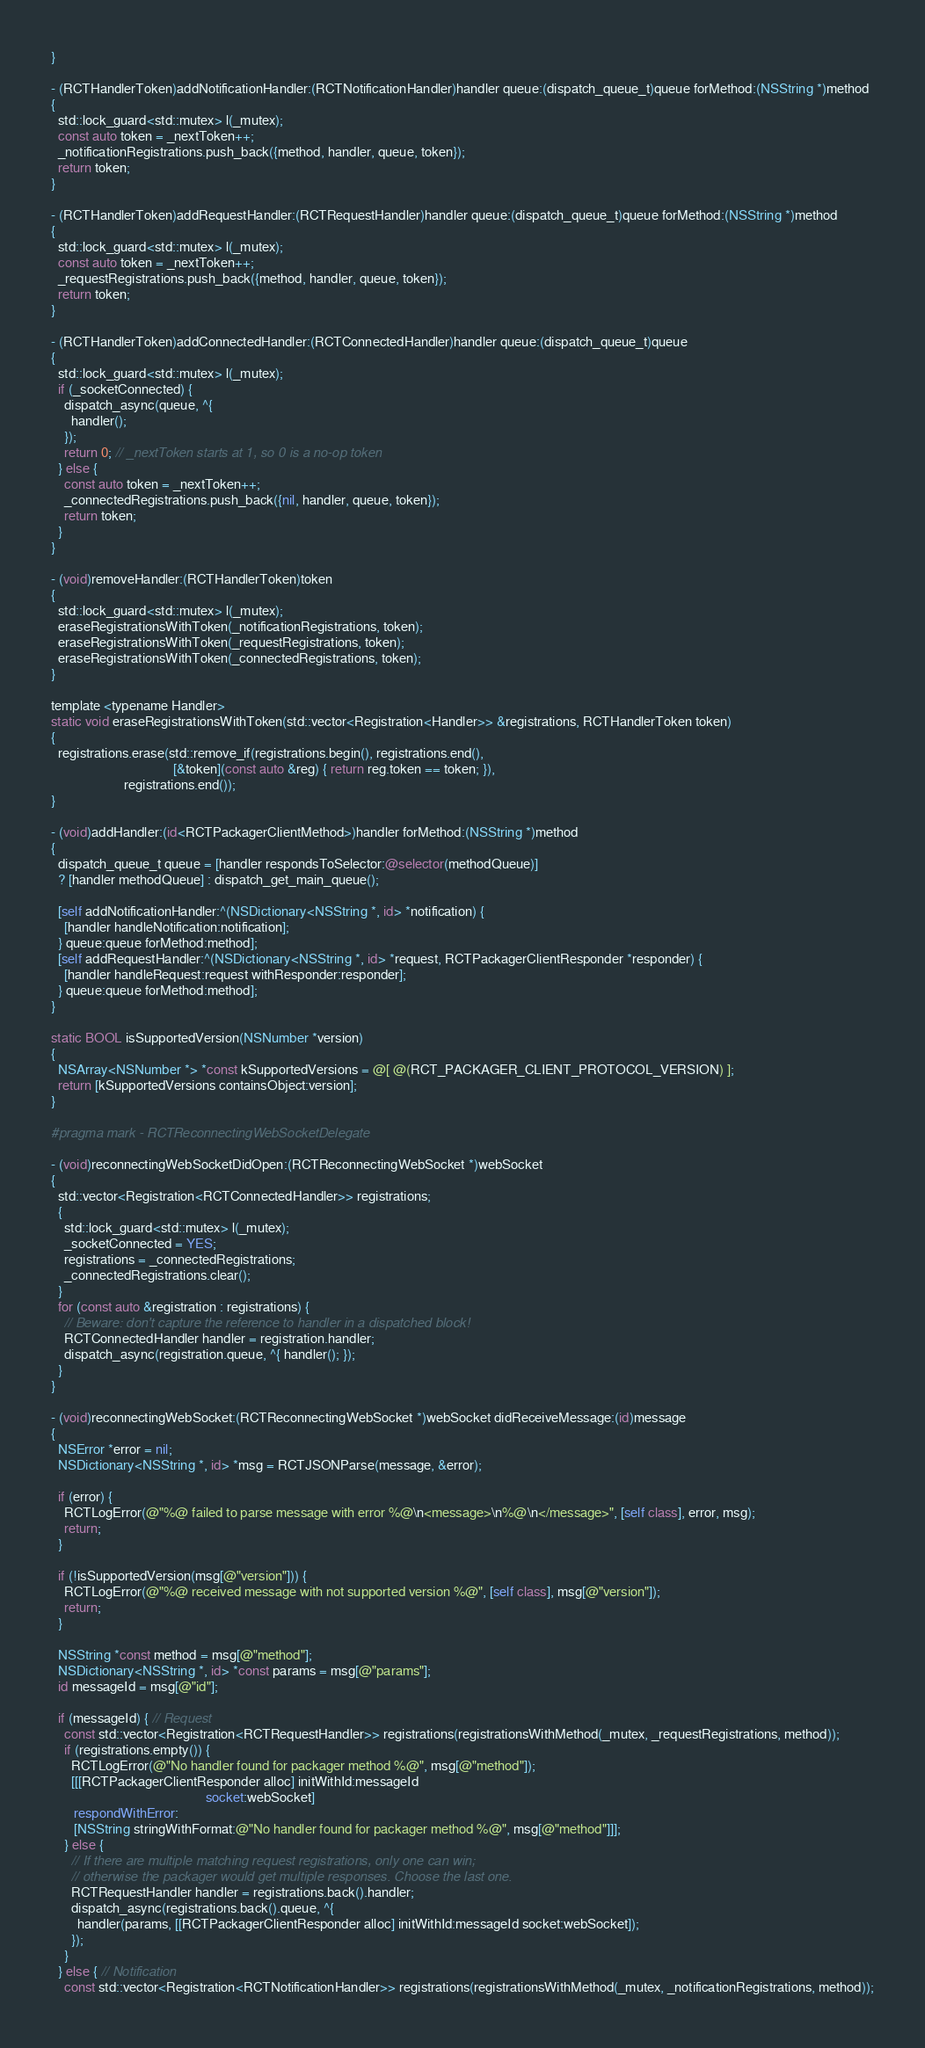<code> <loc_0><loc_0><loc_500><loc_500><_ObjectiveC_>}

- (RCTHandlerToken)addNotificationHandler:(RCTNotificationHandler)handler queue:(dispatch_queue_t)queue forMethod:(NSString *)method
{
  std::lock_guard<std::mutex> l(_mutex);
  const auto token = _nextToken++;
  _notificationRegistrations.push_back({method, handler, queue, token});
  return token;
}

- (RCTHandlerToken)addRequestHandler:(RCTRequestHandler)handler queue:(dispatch_queue_t)queue forMethod:(NSString *)method
{
  std::lock_guard<std::mutex> l(_mutex);
  const auto token = _nextToken++;
  _requestRegistrations.push_back({method, handler, queue, token});
  return token;
}

- (RCTHandlerToken)addConnectedHandler:(RCTConnectedHandler)handler queue:(dispatch_queue_t)queue
{
  std::lock_guard<std::mutex> l(_mutex);
  if (_socketConnected) {
    dispatch_async(queue, ^{
      handler();
    });
    return 0; // _nextToken starts at 1, so 0 is a no-op token
  } else {
    const auto token = _nextToken++;
    _connectedRegistrations.push_back({nil, handler, queue, token});
    return token;
  }
}

- (void)removeHandler:(RCTHandlerToken)token
{
  std::lock_guard<std::mutex> l(_mutex);
  eraseRegistrationsWithToken(_notificationRegistrations, token);
  eraseRegistrationsWithToken(_requestRegistrations, token);
  eraseRegistrationsWithToken(_connectedRegistrations, token);
}

template <typename Handler>
static void eraseRegistrationsWithToken(std::vector<Registration<Handler>> &registrations, RCTHandlerToken token)
{
  registrations.erase(std::remove_if(registrations.begin(), registrations.end(),
                                     [&token](const auto &reg) { return reg.token == token; }),
                      registrations.end());
}

- (void)addHandler:(id<RCTPackagerClientMethod>)handler forMethod:(NSString *)method
{
  dispatch_queue_t queue = [handler respondsToSelector:@selector(methodQueue)]
  ? [handler methodQueue] : dispatch_get_main_queue();

  [self addNotificationHandler:^(NSDictionary<NSString *, id> *notification) {
    [handler handleNotification:notification];
  } queue:queue forMethod:method];
  [self addRequestHandler:^(NSDictionary<NSString *, id> *request, RCTPackagerClientResponder *responder) {
    [handler handleRequest:request withResponder:responder];
  } queue:queue forMethod:method];
}

static BOOL isSupportedVersion(NSNumber *version)
{
  NSArray<NSNumber *> *const kSupportedVersions = @[ @(RCT_PACKAGER_CLIENT_PROTOCOL_VERSION) ];
  return [kSupportedVersions containsObject:version];
}

#pragma mark - RCTReconnectingWebSocketDelegate

- (void)reconnectingWebSocketDidOpen:(RCTReconnectingWebSocket *)webSocket
{
  std::vector<Registration<RCTConnectedHandler>> registrations;
  {
    std::lock_guard<std::mutex> l(_mutex);
    _socketConnected = YES;
    registrations = _connectedRegistrations;
    _connectedRegistrations.clear();
  }
  for (const auto &registration : registrations) {
    // Beware: don't capture the reference to handler in a dispatched block!
    RCTConnectedHandler handler = registration.handler;
    dispatch_async(registration.queue, ^{ handler(); });
  }
}

- (void)reconnectingWebSocket:(RCTReconnectingWebSocket *)webSocket didReceiveMessage:(id)message
{
  NSError *error = nil;
  NSDictionary<NSString *, id> *msg = RCTJSONParse(message, &error);

  if (error) {
    RCTLogError(@"%@ failed to parse message with error %@\n<message>\n%@\n</message>", [self class], error, msg);
    return;
  }

  if (!isSupportedVersion(msg[@"version"])) {
    RCTLogError(@"%@ received message with not supported version %@", [self class], msg[@"version"]);
    return;
  }

  NSString *const method = msg[@"method"];
  NSDictionary<NSString *, id> *const params = msg[@"params"];
  id messageId = msg[@"id"];

  if (messageId) { // Request
    const std::vector<Registration<RCTRequestHandler>> registrations(registrationsWithMethod(_mutex, _requestRegistrations, method));
    if (registrations.empty()) {
      RCTLogError(@"No handler found for packager method %@", msg[@"method"]);
      [[[RCTPackagerClientResponder alloc] initWithId:messageId
                                               socket:webSocket]
       respondWithError:
       [NSString stringWithFormat:@"No handler found for packager method %@", msg[@"method"]]];
    } else {
      // If there are multiple matching request registrations, only one can win;
      // otherwise the packager would get multiple responses. Choose the last one.
      RCTRequestHandler handler = registrations.back().handler;
      dispatch_async(registrations.back().queue, ^{
        handler(params, [[RCTPackagerClientResponder alloc] initWithId:messageId socket:webSocket]);
      });
    }
  } else { // Notification
    const std::vector<Registration<RCTNotificationHandler>> registrations(registrationsWithMethod(_mutex, _notificationRegistrations, method));</code> 